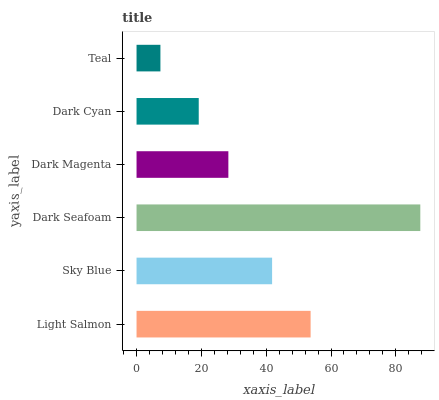Is Teal the minimum?
Answer yes or no. Yes. Is Dark Seafoam the maximum?
Answer yes or no. Yes. Is Sky Blue the minimum?
Answer yes or no. No. Is Sky Blue the maximum?
Answer yes or no. No. Is Light Salmon greater than Sky Blue?
Answer yes or no. Yes. Is Sky Blue less than Light Salmon?
Answer yes or no. Yes. Is Sky Blue greater than Light Salmon?
Answer yes or no. No. Is Light Salmon less than Sky Blue?
Answer yes or no. No. Is Sky Blue the high median?
Answer yes or no. Yes. Is Dark Magenta the low median?
Answer yes or no. Yes. Is Teal the high median?
Answer yes or no. No. Is Dark Cyan the low median?
Answer yes or no. No. 